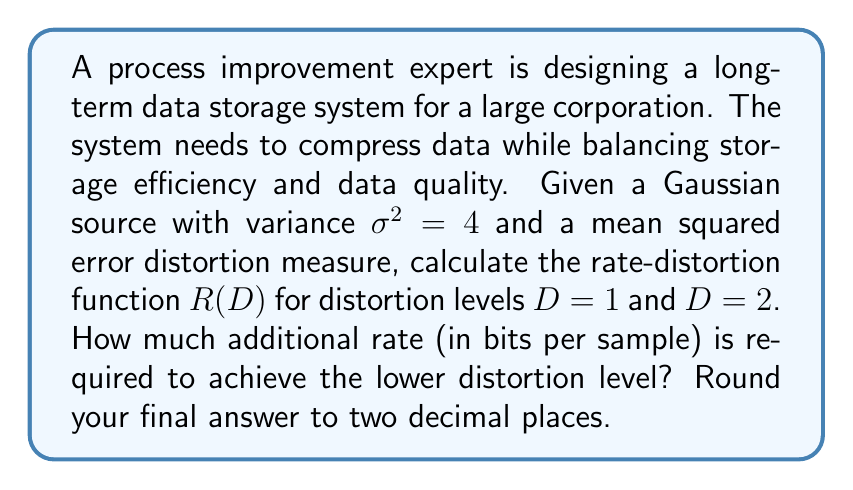Could you help me with this problem? To solve this problem, we'll follow these steps:

1. Recall the rate-distortion function for a Gaussian source with variance $\sigma^2$ and mean squared error distortion:

   $$R(D) = \begin{cases}
   \frac{1}{2} \log_2 \left(\frac{\sigma^2}{D}\right) & \text{if } 0 \leq D \leq \sigma^2 \\
   0 & \text{if } D > \sigma^2
   \end{cases}$$

2. Calculate $R(D)$ for $D = 1$:
   $$R(1) = \frac{1}{2} \log_2 \left(\frac{4}{1}\right) = \frac{1}{2} \log_2(4) = 1 \text{ bit/sample}$$

3. Calculate $R(D)$ for $D = 2$:
   $$R(2) = \frac{1}{2} \log_2 \left(\frac{4}{2}\right) = \frac{1}{2} \log_2(2) = 0.5 \text{ bits/sample}$$

4. Calculate the difference in rates:
   $$\Delta R = R(1) - R(2) = 1 - 0.5 = 0.5 \text{ bits/sample}$$

This result shows that to achieve the lower distortion level (D = 1), an additional 0.5 bits per sample are required compared to the higher distortion level (D = 2).
Answer: 0.50 bits/sample 